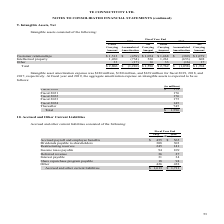According to Te Connectivity's financial document, What was the amount of Accrued and other current liabilities in 2019? According to the financial document, $ 1,613 (in millions). The relevant text states: "Accrued and other current liabilities $ 1,613 $ 1,711..." Also, In which years was Accrued and Other Current Liabilities calculated for? The document shows two values: 2019 and 2018. From the document: "2019 2018 2019 2018..." Also, What are the components which comprise of Accrued and Other Current Liabilities? The document contains multiple relevant values: Accrued payroll and employee benefits, Dividends payable to shareholders, Restructuring reserves, Income taxes payable, Deferred revenue, Interest payable, Share repurchase program payable, Other. From the document: "Interest payable 31 34 Restructuring reserves 245 141 Accrued payroll and employee benefits $ 455 $ 565 Income taxes payable 94 109 Other 426 438 Shar..." Additionally, In which year was the amount of Deferred revenue larger? According to the financial document, 2019. The relevant text states: "2019 2018..." Also, can you calculate: What was the change in deferred revenue in 2019 from 2018? Based on the calculation: 36-27, the result is 9 (in millions). This is based on the information: "Deferred revenue 36 27 Deferred revenue 36 27..." The key data points involved are: 27, 36. Also, can you calculate: What was the percentage change in deferred revenue in 2019 from 2018? To answer this question, I need to perform calculations using the financial data. The calculation is: (36-27)/27, which equals 33.33 (percentage). This is based on the information: "Deferred revenue 36 27 Deferred revenue 36 27..." The key data points involved are: 27, 36. 